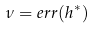<formula> <loc_0><loc_0><loc_500><loc_500>\nu = e r r ( h ^ { * } )</formula> 